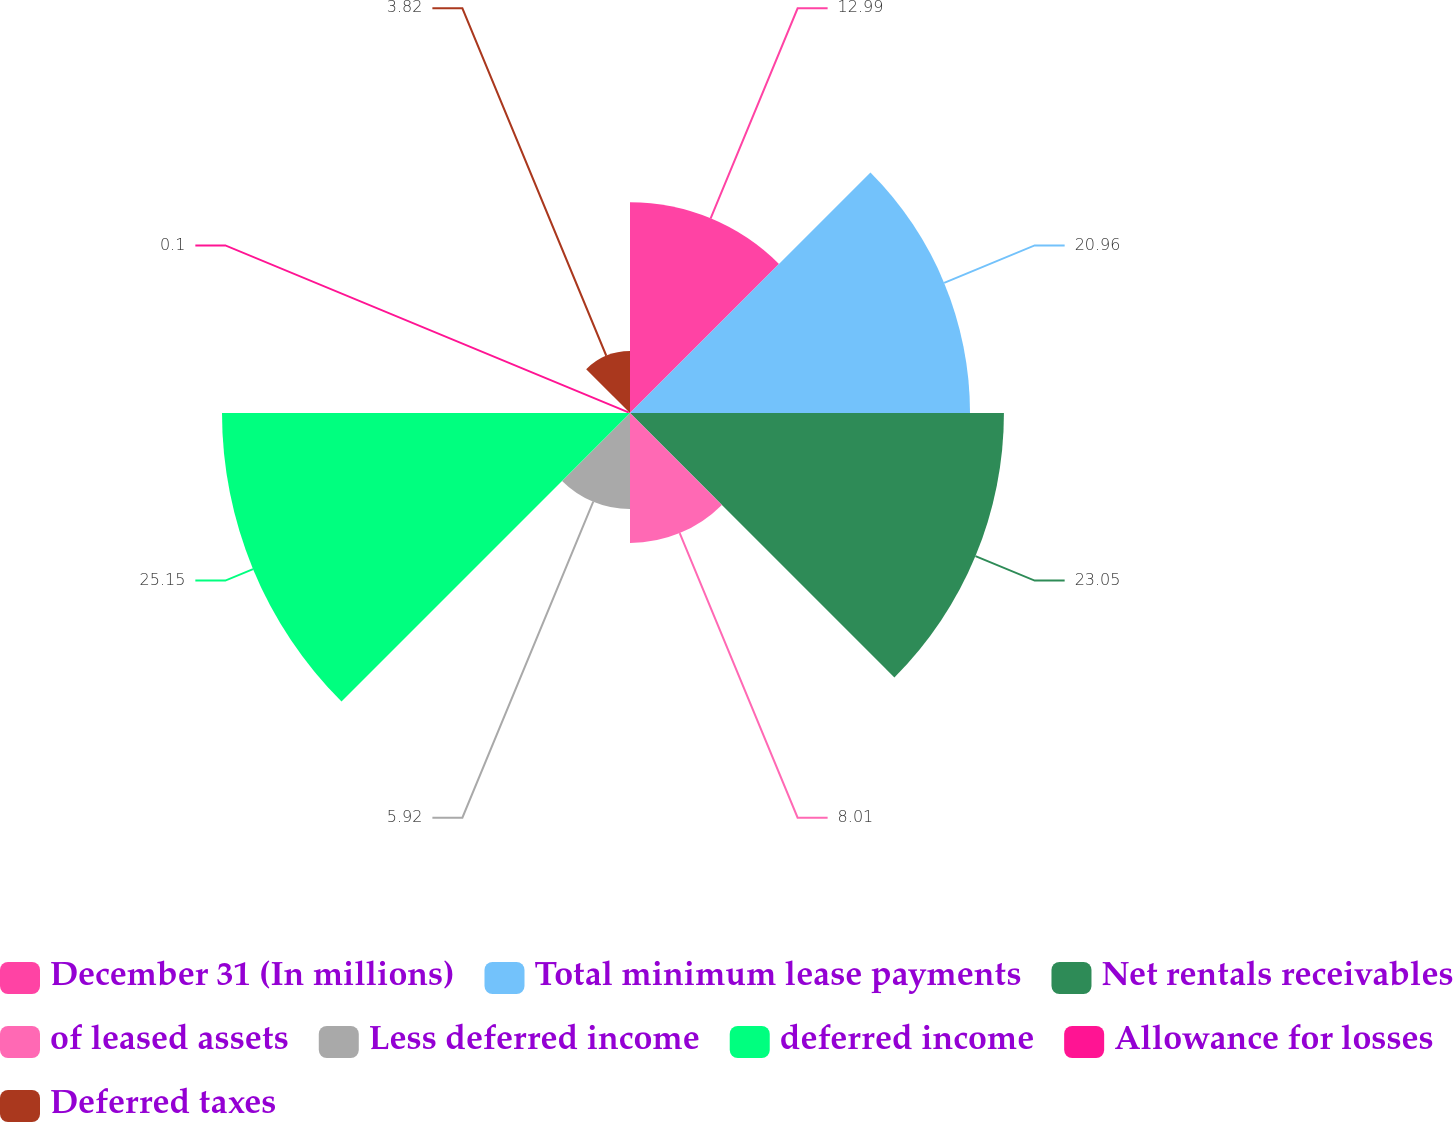Convert chart to OTSL. <chart><loc_0><loc_0><loc_500><loc_500><pie_chart><fcel>December 31 (In millions)<fcel>Total minimum lease payments<fcel>Net rentals receivables<fcel>of leased assets<fcel>Less deferred income<fcel>deferred income<fcel>Allowance for losses<fcel>Deferred taxes<nl><fcel>12.99%<fcel>20.96%<fcel>23.05%<fcel>8.01%<fcel>5.92%<fcel>25.15%<fcel>0.1%<fcel>3.82%<nl></chart> 